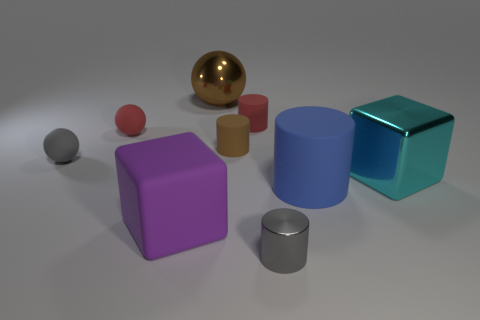Which is the largest object in this scene, and what color is it? The largest object in the scene is the blue cylinder. It stands out due to its size compared to the other objects. Is that the only blue object present in the image? No, there is another smaller object that is also blue—a small cube. 